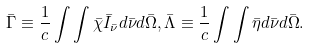<formula> <loc_0><loc_0><loc_500><loc_500>\bar { \Gamma } \equiv \frac { 1 } { c } \int \int \bar { \chi } \bar { I } _ { \bar { \nu } } d \bar { \nu } d \bar { \Omega } , \bar { \Lambda } \equiv \frac { 1 } { c } \int \int \bar { \eta } d \bar { \nu } d \bar { \Omega } .</formula> 